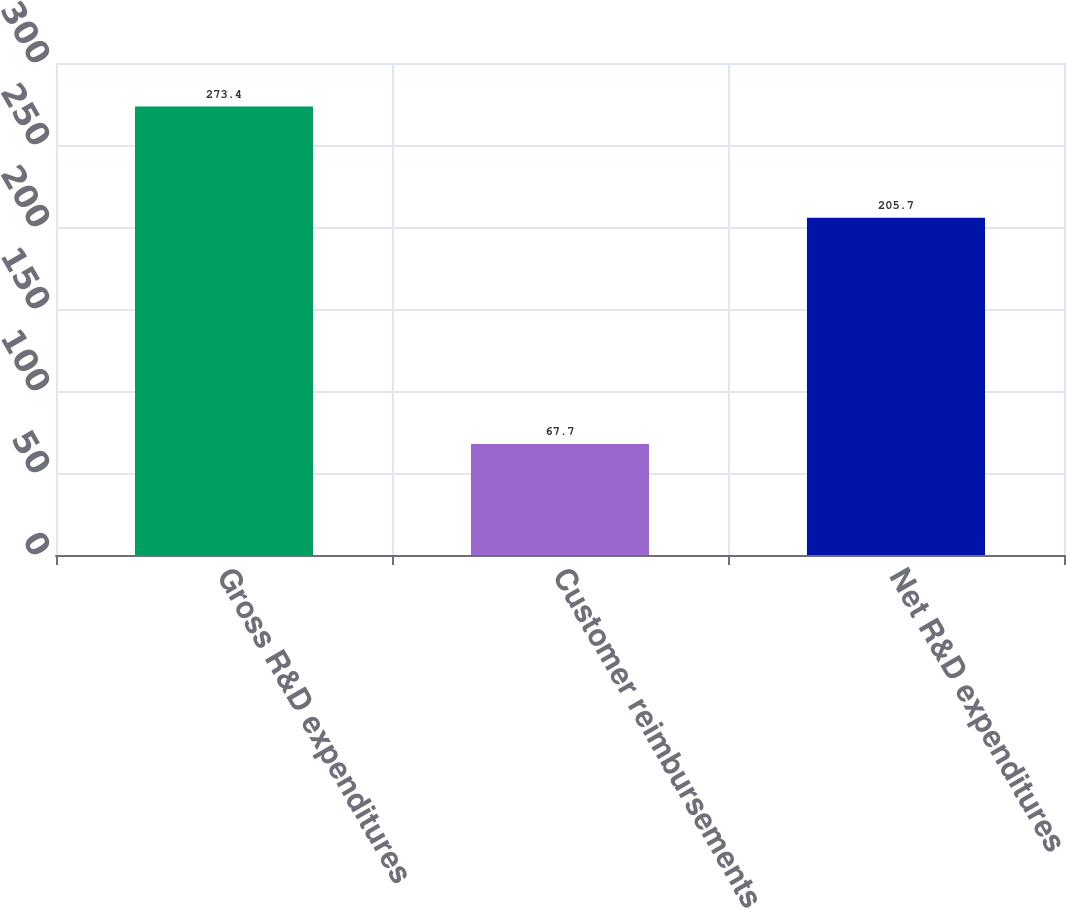<chart> <loc_0><loc_0><loc_500><loc_500><bar_chart><fcel>Gross R&D expenditures<fcel>Customer reimbursements<fcel>Net R&D expenditures<nl><fcel>273.4<fcel>67.7<fcel>205.7<nl></chart> 